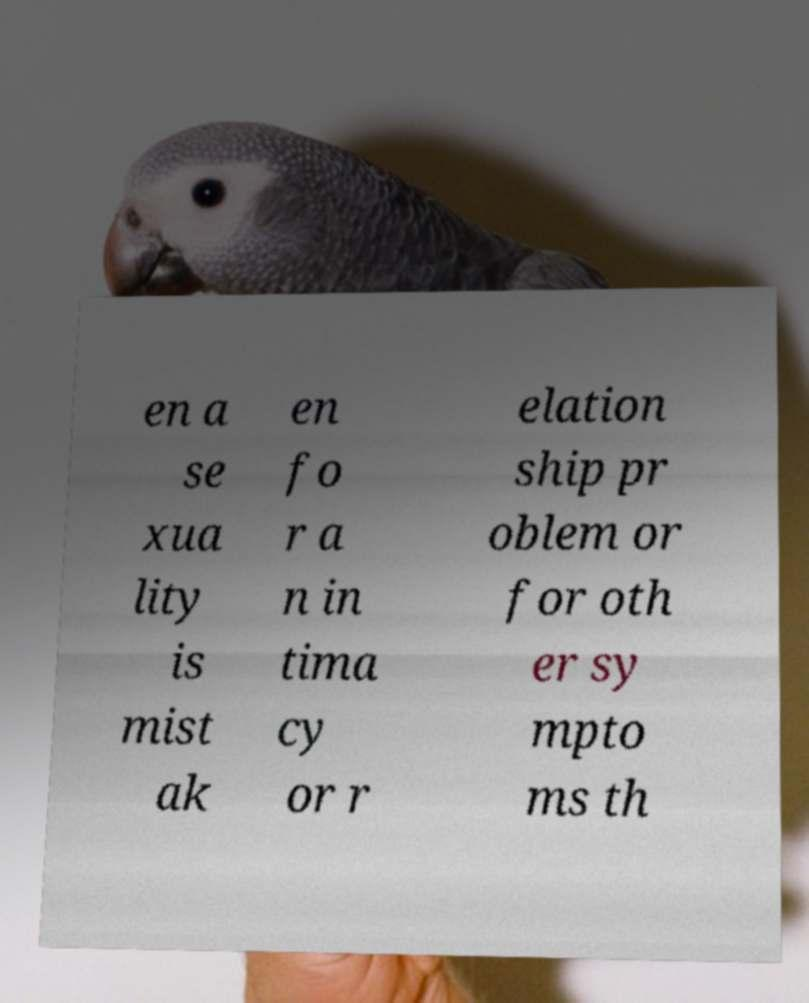Can you accurately transcribe the text from the provided image for me? en a se xua lity is mist ak en fo r a n in tima cy or r elation ship pr oblem or for oth er sy mpto ms th 